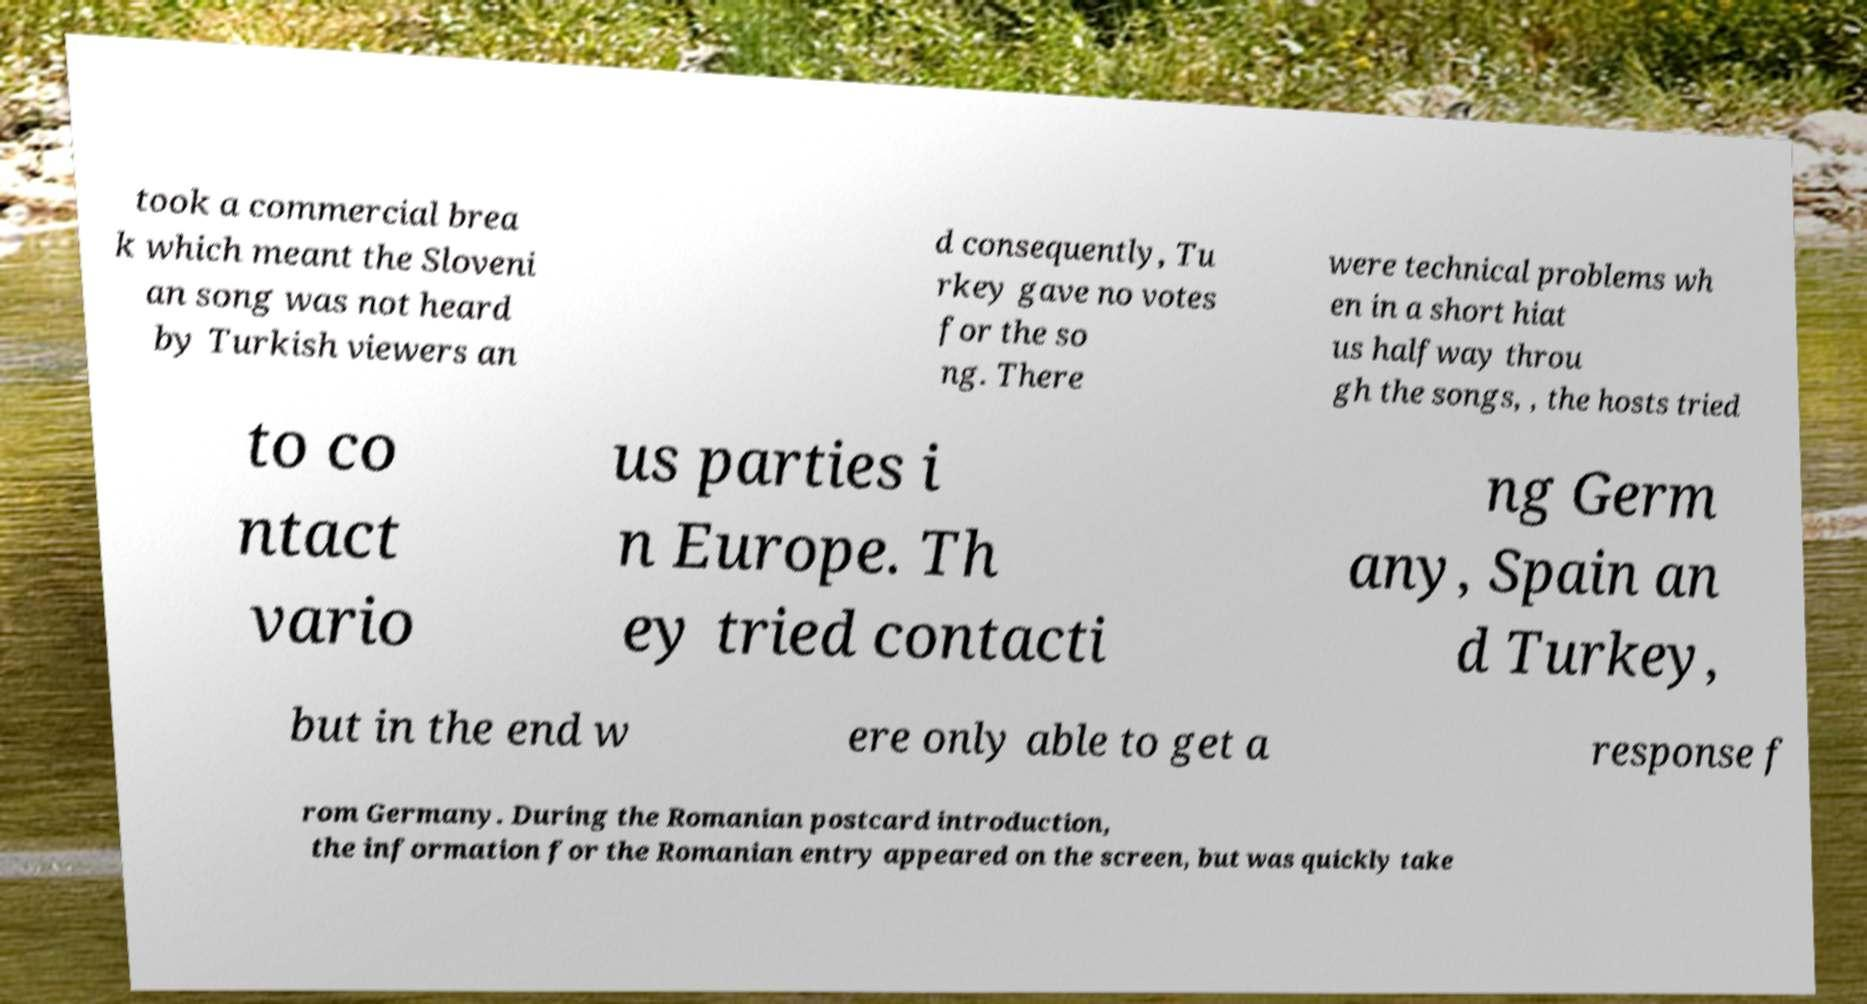Can you read and provide the text displayed in the image?This photo seems to have some interesting text. Can you extract and type it out for me? took a commercial brea k which meant the Sloveni an song was not heard by Turkish viewers an d consequently, Tu rkey gave no votes for the so ng. There were technical problems wh en in a short hiat us halfway throu gh the songs, , the hosts tried to co ntact vario us parties i n Europe. Th ey tried contacti ng Germ any, Spain an d Turkey, but in the end w ere only able to get a response f rom Germany. During the Romanian postcard introduction, the information for the Romanian entry appeared on the screen, but was quickly take 